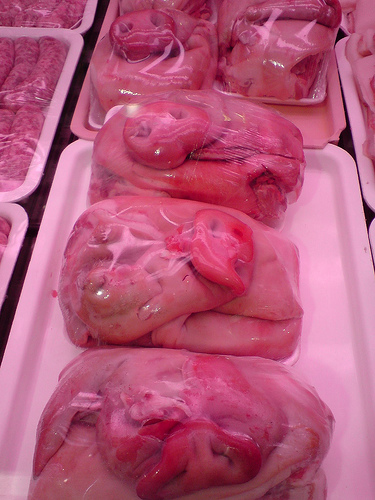<image>
Is there a sausage in the pigs head? No. The sausage is not contained within the pigs head. These objects have a different spatial relationship. Is the pig snout next to the sausages? Yes. The pig snout is positioned adjacent to the sausages, located nearby in the same general area. 